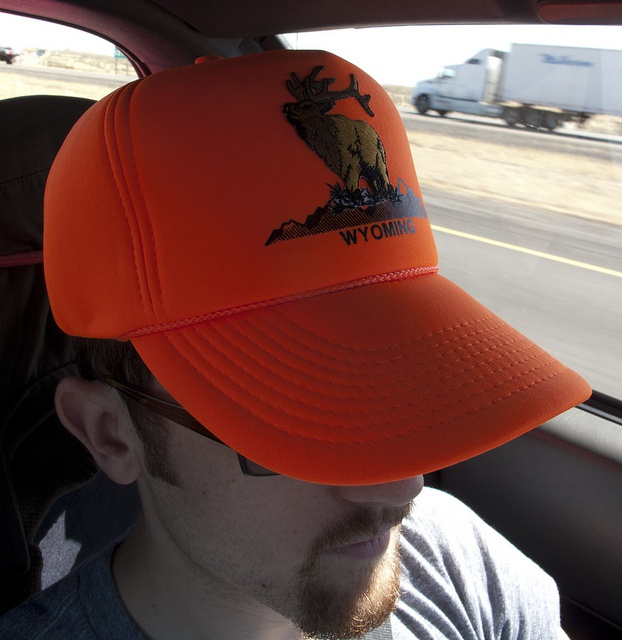Describe the objects in this image and their specific colors. I can see people in brown, black, gray, and white tones and truck in brown, lightgray, darkgray, and gray tones in this image. 